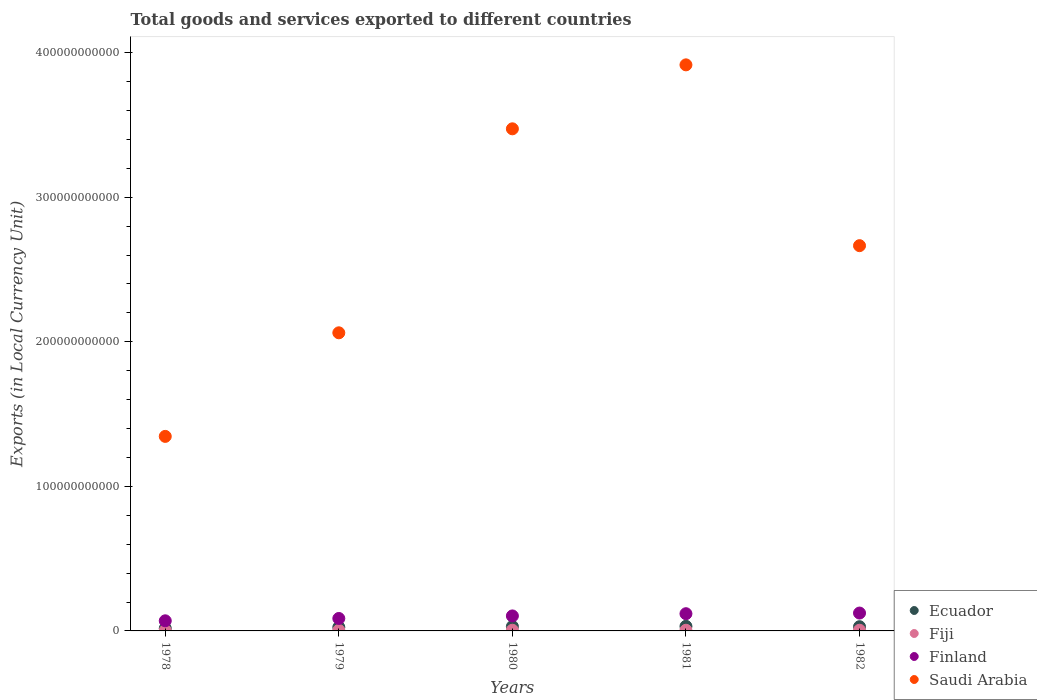What is the Amount of goods and services exports in Saudi Arabia in 1980?
Your response must be concise. 3.47e+11. Across all years, what is the maximum Amount of goods and services exports in Ecuador?
Keep it short and to the point. 3.19e+09. Across all years, what is the minimum Amount of goods and services exports in Ecuador?
Offer a very short reply. 1.76e+09. In which year was the Amount of goods and services exports in Saudi Arabia minimum?
Keep it short and to the point. 1978. What is the total Amount of goods and services exports in Finland in the graph?
Offer a very short reply. 5.03e+1. What is the difference between the Amount of goods and services exports in Ecuador in 1980 and that in 1982?
Your answer should be very brief. 1.45e+08. What is the difference between the Amount of goods and services exports in Finland in 1979 and the Amount of goods and services exports in Fiji in 1982?
Your answer should be very brief. 8.13e+09. What is the average Amount of goods and services exports in Fiji per year?
Provide a short and direct response. 4.18e+08. In the year 1982, what is the difference between the Amount of goods and services exports in Finland and Amount of goods and services exports in Ecuador?
Offer a terse response. 9.44e+09. What is the ratio of the Amount of goods and services exports in Ecuador in 1981 to that in 1982?
Your answer should be compact. 1.09. What is the difference between the highest and the second highest Amount of goods and services exports in Saudi Arabia?
Give a very brief answer. 4.42e+1. What is the difference between the highest and the lowest Amount of goods and services exports in Ecuador?
Keep it short and to the point. 1.43e+09. Is the sum of the Amount of goods and services exports in Ecuador in 1978 and 1982 greater than the maximum Amount of goods and services exports in Saudi Arabia across all years?
Give a very brief answer. No. Is it the case that in every year, the sum of the Amount of goods and services exports in Fiji and Amount of goods and services exports in Saudi Arabia  is greater than the sum of Amount of goods and services exports in Finland and Amount of goods and services exports in Ecuador?
Make the answer very short. Yes. Is it the case that in every year, the sum of the Amount of goods and services exports in Finland and Amount of goods and services exports in Ecuador  is greater than the Amount of goods and services exports in Fiji?
Ensure brevity in your answer.  Yes. Does the Amount of goods and services exports in Ecuador monotonically increase over the years?
Your answer should be compact. No. Is the Amount of goods and services exports in Ecuador strictly less than the Amount of goods and services exports in Saudi Arabia over the years?
Your response must be concise. Yes. How many years are there in the graph?
Your response must be concise. 5. What is the difference between two consecutive major ticks on the Y-axis?
Provide a succinct answer. 1.00e+11. Are the values on the major ticks of Y-axis written in scientific E-notation?
Give a very brief answer. No. Where does the legend appear in the graph?
Ensure brevity in your answer.  Bottom right. How many legend labels are there?
Give a very brief answer. 4. How are the legend labels stacked?
Your response must be concise. Vertical. What is the title of the graph?
Provide a succinct answer. Total goods and services exported to different countries. What is the label or title of the Y-axis?
Give a very brief answer. Exports (in Local Currency Unit). What is the Exports (in Local Currency Unit) of Ecuador in 1978?
Offer a very short reply. 1.76e+09. What is the Exports (in Local Currency Unit) of Fiji in 1978?
Ensure brevity in your answer.  3.00e+08. What is the Exports (in Local Currency Unit) in Finland in 1978?
Make the answer very short. 7.00e+09. What is the Exports (in Local Currency Unit) of Saudi Arabia in 1978?
Your answer should be compact. 1.35e+11. What is the Exports (in Local Currency Unit) in Ecuador in 1979?
Provide a succinct answer. 2.54e+09. What is the Exports (in Local Currency Unit) in Fiji in 1979?
Your answer should be compact. 3.86e+08. What is the Exports (in Local Currency Unit) in Finland in 1979?
Your answer should be very brief. 8.62e+09. What is the Exports (in Local Currency Unit) in Saudi Arabia in 1979?
Your answer should be very brief. 2.06e+11. What is the Exports (in Local Currency Unit) of Ecuador in 1980?
Your response must be concise. 3.06e+09. What is the Exports (in Local Currency Unit) of Fiji in 1980?
Your answer should be very brief. 4.70e+08. What is the Exports (in Local Currency Unit) in Finland in 1980?
Offer a very short reply. 1.04e+1. What is the Exports (in Local Currency Unit) in Saudi Arabia in 1980?
Your response must be concise. 3.47e+11. What is the Exports (in Local Currency Unit) of Ecuador in 1981?
Ensure brevity in your answer.  3.19e+09. What is the Exports (in Local Currency Unit) in Fiji in 1981?
Your answer should be very brief. 4.54e+08. What is the Exports (in Local Currency Unit) of Finland in 1981?
Offer a terse response. 1.19e+1. What is the Exports (in Local Currency Unit) of Saudi Arabia in 1981?
Your answer should be compact. 3.92e+11. What is the Exports (in Local Currency Unit) in Ecuador in 1982?
Provide a succinct answer. 2.92e+09. What is the Exports (in Local Currency Unit) in Fiji in 1982?
Ensure brevity in your answer.  4.81e+08. What is the Exports (in Local Currency Unit) of Finland in 1982?
Offer a terse response. 1.24e+1. What is the Exports (in Local Currency Unit) of Saudi Arabia in 1982?
Your answer should be very brief. 2.67e+11. Across all years, what is the maximum Exports (in Local Currency Unit) in Ecuador?
Give a very brief answer. 3.19e+09. Across all years, what is the maximum Exports (in Local Currency Unit) in Fiji?
Provide a short and direct response. 4.81e+08. Across all years, what is the maximum Exports (in Local Currency Unit) of Finland?
Give a very brief answer. 1.24e+1. Across all years, what is the maximum Exports (in Local Currency Unit) of Saudi Arabia?
Offer a very short reply. 3.92e+11. Across all years, what is the minimum Exports (in Local Currency Unit) in Ecuador?
Make the answer very short. 1.76e+09. Across all years, what is the minimum Exports (in Local Currency Unit) in Fiji?
Your response must be concise. 3.00e+08. Across all years, what is the minimum Exports (in Local Currency Unit) of Finland?
Give a very brief answer. 7.00e+09. Across all years, what is the minimum Exports (in Local Currency Unit) of Saudi Arabia?
Your answer should be compact. 1.35e+11. What is the total Exports (in Local Currency Unit) in Ecuador in the graph?
Your response must be concise. 1.35e+1. What is the total Exports (in Local Currency Unit) of Fiji in the graph?
Keep it short and to the point. 2.09e+09. What is the total Exports (in Local Currency Unit) in Finland in the graph?
Offer a very short reply. 5.03e+1. What is the total Exports (in Local Currency Unit) of Saudi Arabia in the graph?
Your response must be concise. 1.35e+12. What is the difference between the Exports (in Local Currency Unit) of Ecuador in 1978 and that in 1979?
Provide a succinct answer. -7.82e+08. What is the difference between the Exports (in Local Currency Unit) of Fiji in 1978 and that in 1979?
Offer a terse response. -8.63e+07. What is the difference between the Exports (in Local Currency Unit) of Finland in 1978 and that in 1979?
Give a very brief answer. -1.62e+09. What is the difference between the Exports (in Local Currency Unit) of Saudi Arabia in 1978 and that in 1979?
Give a very brief answer. -7.17e+1. What is the difference between the Exports (in Local Currency Unit) in Ecuador in 1978 and that in 1980?
Provide a succinct answer. -1.31e+09. What is the difference between the Exports (in Local Currency Unit) in Fiji in 1978 and that in 1980?
Your answer should be very brief. -1.71e+08. What is the difference between the Exports (in Local Currency Unit) in Finland in 1978 and that in 1980?
Ensure brevity in your answer.  -3.38e+09. What is the difference between the Exports (in Local Currency Unit) in Saudi Arabia in 1978 and that in 1980?
Give a very brief answer. -2.13e+11. What is the difference between the Exports (in Local Currency Unit) of Ecuador in 1978 and that in 1981?
Keep it short and to the point. -1.43e+09. What is the difference between the Exports (in Local Currency Unit) of Fiji in 1978 and that in 1981?
Ensure brevity in your answer.  -1.55e+08. What is the difference between the Exports (in Local Currency Unit) of Finland in 1978 and that in 1981?
Keep it short and to the point. -4.92e+09. What is the difference between the Exports (in Local Currency Unit) in Saudi Arabia in 1978 and that in 1981?
Your response must be concise. -2.57e+11. What is the difference between the Exports (in Local Currency Unit) of Ecuador in 1978 and that in 1982?
Your response must be concise. -1.16e+09. What is the difference between the Exports (in Local Currency Unit) in Fiji in 1978 and that in 1982?
Keep it short and to the point. -1.82e+08. What is the difference between the Exports (in Local Currency Unit) in Finland in 1978 and that in 1982?
Make the answer very short. -5.36e+09. What is the difference between the Exports (in Local Currency Unit) of Saudi Arabia in 1978 and that in 1982?
Provide a succinct answer. -1.32e+11. What is the difference between the Exports (in Local Currency Unit) in Ecuador in 1979 and that in 1980?
Provide a succinct answer. -5.28e+08. What is the difference between the Exports (in Local Currency Unit) of Fiji in 1979 and that in 1980?
Your response must be concise. -8.42e+07. What is the difference between the Exports (in Local Currency Unit) of Finland in 1979 and that in 1980?
Offer a terse response. -1.76e+09. What is the difference between the Exports (in Local Currency Unit) in Saudi Arabia in 1979 and that in 1980?
Offer a terse response. -1.41e+11. What is the difference between the Exports (in Local Currency Unit) in Ecuador in 1979 and that in 1981?
Your answer should be compact. -6.49e+08. What is the difference between the Exports (in Local Currency Unit) of Fiji in 1979 and that in 1981?
Provide a short and direct response. -6.86e+07. What is the difference between the Exports (in Local Currency Unit) in Finland in 1979 and that in 1981?
Your response must be concise. -3.29e+09. What is the difference between the Exports (in Local Currency Unit) of Saudi Arabia in 1979 and that in 1981?
Provide a succinct answer. -1.85e+11. What is the difference between the Exports (in Local Currency Unit) in Ecuador in 1979 and that in 1982?
Keep it short and to the point. -3.82e+08. What is the difference between the Exports (in Local Currency Unit) in Fiji in 1979 and that in 1982?
Provide a succinct answer. -9.55e+07. What is the difference between the Exports (in Local Currency Unit) in Finland in 1979 and that in 1982?
Provide a short and direct response. -3.74e+09. What is the difference between the Exports (in Local Currency Unit) of Saudi Arabia in 1979 and that in 1982?
Offer a terse response. -6.03e+1. What is the difference between the Exports (in Local Currency Unit) in Ecuador in 1980 and that in 1981?
Ensure brevity in your answer.  -1.22e+08. What is the difference between the Exports (in Local Currency Unit) of Fiji in 1980 and that in 1981?
Your response must be concise. 1.56e+07. What is the difference between the Exports (in Local Currency Unit) of Finland in 1980 and that in 1981?
Your answer should be compact. -1.54e+09. What is the difference between the Exports (in Local Currency Unit) in Saudi Arabia in 1980 and that in 1981?
Provide a short and direct response. -4.42e+1. What is the difference between the Exports (in Local Currency Unit) in Ecuador in 1980 and that in 1982?
Keep it short and to the point. 1.45e+08. What is the difference between the Exports (in Local Currency Unit) of Fiji in 1980 and that in 1982?
Your answer should be compact. -1.13e+07. What is the difference between the Exports (in Local Currency Unit) of Finland in 1980 and that in 1982?
Your answer should be compact. -1.98e+09. What is the difference between the Exports (in Local Currency Unit) of Saudi Arabia in 1980 and that in 1982?
Your answer should be very brief. 8.08e+1. What is the difference between the Exports (in Local Currency Unit) of Ecuador in 1981 and that in 1982?
Keep it short and to the point. 2.67e+08. What is the difference between the Exports (in Local Currency Unit) in Fiji in 1981 and that in 1982?
Ensure brevity in your answer.  -2.69e+07. What is the difference between the Exports (in Local Currency Unit) in Finland in 1981 and that in 1982?
Keep it short and to the point. -4.49e+08. What is the difference between the Exports (in Local Currency Unit) in Saudi Arabia in 1981 and that in 1982?
Offer a very short reply. 1.25e+11. What is the difference between the Exports (in Local Currency Unit) of Ecuador in 1978 and the Exports (in Local Currency Unit) of Fiji in 1979?
Your answer should be very brief. 1.37e+09. What is the difference between the Exports (in Local Currency Unit) of Ecuador in 1978 and the Exports (in Local Currency Unit) of Finland in 1979?
Your answer should be very brief. -6.86e+09. What is the difference between the Exports (in Local Currency Unit) in Ecuador in 1978 and the Exports (in Local Currency Unit) in Saudi Arabia in 1979?
Ensure brevity in your answer.  -2.04e+11. What is the difference between the Exports (in Local Currency Unit) in Fiji in 1978 and the Exports (in Local Currency Unit) in Finland in 1979?
Keep it short and to the point. -8.32e+09. What is the difference between the Exports (in Local Currency Unit) in Fiji in 1978 and the Exports (in Local Currency Unit) in Saudi Arabia in 1979?
Provide a short and direct response. -2.06e+11. What is the difference between the Exports (in Local Currency Unit) in Finland in 1978 and the Exports (in Local Currency Unit) in Saudi Arabia in 1979?
Provide a short and direct response. -1.99e+11. What is the difference between the Exports (in Local Currency Unit) of Ecuador in 1978 and the Exports (in Local Currency Unit) of Fiji in 1980?
Your answer should be compact. 1.29e+09. What is the difference between the Exports (in Local Currency Unit) in Ecuador in 1978 and the Exports (in Local Currency Unit) in Finland in 1980?
Offer a very short reply. -8.62e+09. What is the difference between the Exports (in Local Currency Unit) in Ecuador in 1978 and the Exports (in Local Currency Unit) in Saudi Arabia in 1980?
Your response must be concise. -3.46e+11. What is the difference between the Exports (in Local Currency Unit) in Fiji in 1978 and the Exports (in Local Currency Unit) in Finland in 1980?
Your answer should be very brief. -1.01e+1. What is the difference between the Exports (in Local Currency Unit) in Fiji in 1978 and the Exports (in Local Currency Unit) in Saudi Arabia in 1980?
Provide a short and direct response. -3.47e+11. What is the difference between the Exports (in Local Currency Unit) of Finland in 1978 and the Exports (in Local Currency Unit) of Saudi Arabia in 1980?
Your answer should be very brief. -3.40e+11. What is the difference between the Exports (in Local Currency Unit) of Ecuador in 1978 and the Exports (in Local Currency Unit) of Fiji in 1981?
Offer a terse response. 1.30e+09. What is the difference between the Exports (in Local Currency Unit) in Ecuador in 1978 and the Exports (in Local Currency Unit) in Finland in 1981?
Keep it short and to the point. -1.02e+1. What is the difference between the Exports (in Local Currency Unit) in Ecuador in 1978 and the Exports (in Local Currency Unit) in Saudi Arabia in 1981?
Give a very brief answer. -3.90e+11. What is the difference between the Exports (in Local Currency Unit) of Fiji in 1978 and the Exports (in Local Currency Unit) of Finland in 1981?
Keep it short and to the point. -1.16e+1. What is the difference between the Exports (in Local Currency Unit) of Fiji in 1978 and the Exports (in Local Currency Unit) of Saudi Arabia in 1981?
Ensure brevity in your answer.  -3.91e+11. What is the difference between the Exports (in Local Currency Unit) of Finland in 1978 and the Exports (in Local Currency Unit) of Saudi Arabia in 1981?
Give a very brief answer. -3.85e+11. What is the difference between the Exports (in Local Currency Unit) in Ecuador in 1978 and the Exports (in Local Currency Unit) in Fiji in 1982?
Make the answer very short. 1.27e+09. What is the difference between the Exports (in Local Currency Unit) in Ecuador in 1978 and the Exports (in Local Currency Unit) in Finland in 1982?
Offer a very short reply. -1.06e+1. What is the difference between the Exports (in Local Currency Unit) of Ecuador in 1978 and the Exports (in Local Currency Unit) of Saudi Arabia in 1982?
Provide a short and direct response. -2.65e+11. What is the difference between the Exports (in Local Currency Unit) in Fiji in 1978 and the Exports (in Local Currency Unit) in Finland in 1982?
Your answer should be compact. -1.21e+1. What is the difference between the Exports (in Local Currency Unit) of Fiji in 1978 and the Exports (in Local Currency Unit) of Saudi Arabia in 1982?
Offer a terse response. -2.66e+11. What is the difference between the Exports (in Local Currency Unit) in Finland in 1978 and the Exports (in Local Currency Unit) in Saudi Arabia in 1982?
Offer a very short reply. -2.60e+11. What is the difference between the Exports (in Local Currency Unit) of Ecuador in 1979 and the Exports (in Local Currency Unit) of Fiji in 1980?
Your response must be concise. 2.07e+09. What is the difference between the Exports (in Local Currency Unit) of Ecuador in 1979 and the Exports (in Local Currency Unit) of Finland in 1980?
Your response must be concise. -7.84e+09. What is the difference between the Exports (in Local Currency Unit) of Ecuador in 1979 and the Exports (in Local Currency Unit) of Saudi Arabia in 1980?
Make the answer very short. -3.45e+11. What is the difference between the Exports (in Local Currency Unit) in Fiji in 1979 and the Exports (in Local Currency Unit) in Finland in 1980?
Your answer should be very brief. -9.99e+09. What is the difference between the Exports (in Local Currency Unit) in Fiji in 1979 and the Exports (in Local Currency Unit) in Saudi Arabia in 1980?
Offer a terse response. -3.47e+11. What is the difference between the Exports (in Local Currency Unit) in Finland in 1979 and the Exports (in Local Currency Unit) in Saudi Arabia in 1980?
Provide a succinct answer. -3.39e+11. What is the difference between the Exports (in Local Currency Unit) in Ecuador in 1979 and the Exports (in Local Currency Unit) in Fiji in 1981?
Offer a very short reply. 2.08e+09. What is the difference between the Exports (in Local Currency Unit) of Ecuador in 1979 and the Exports (in Local Currency Unit) of Finland in 1981?
Provide a short and direct response. -9.37e+09. What is the difference between the Exports (in Local Currency Unit) in Ecuador in 1979 and the Exports (in Local Currency Unit) in Saudi Arabia in 1981?
Give a very brief answer. -3.89e+11. What is the difference between the Exports (in Local Currency Unit) of Fiji in 1979 and the Exports (in Local Currency Unit) of Finland in 1981?
Your answer should be very brief. -1.15e+1. What is the difference between the Exports (in Local Currency Unit) in Fiji in 1979 and the Exports (in Local Currency Unit) in Saudi Arabia in 1981?
Ensure brevity in your answer.  -3.91e+11. What is the difference between the Exports (in Local Currency Unit) of Finland in 1979 and the Exports (in Local Currency Unit) of Saudi Arabia in 1981?
Your answer should be very brief. -3.83e+11. What is the difference between the Exports (in Local Currency Unit) in Ecuador in 1979 and the Exports (in Local Currency Unit) in Fiji in 1982?
Give a very brief answer. 2.06e+09. What is the difference between the Exports (in Local Currency Unit) in Ecuador in 1979 and the Exports (in Local Currency Unit) in Finland in 1982?
Provide a short and direct response. -9.82e+09. What is the difference between the Exports (in Local Currency Unit) of Ecuador in 1979 and the Exports (in Local Currency Unit) of Saudi Arabia in 1982?
Ensure brevity in your answer.  -2.64e+11. What is the difference between the Exports (in Local Currency Unit) in Fiji in 1979 and the Exports (in Local Currency Unit) in Finland in 1982?
Provide a short and direct response. -1.20e+1. What is the difference between the Exports (in Local Currency Unit) in Fiji in 1979 and the Exports (in Local Currency Unit) in Saudi Arabia in 1982?
Your answer should be very brief. -2.66e+11. What is the difference between the Exports (in Local Currency Unit) of Finland in 1979 and the Exports (in Local Currency Unit) of Saudi Arabia in 1982?
Give a very brief answer. -2.58e+11. What is the difference between the Exports (in Local Currency Unit) in Ecuador in 1980 and the Exports (in Local Currency Unit) in Fiji in 1981?
Your answer should be compact. 2.61e+09. What is the difference between the Exports (in Local Currency Unit) of Ecuador in 1980 and the Exports (in Local Currency Unit) of Finland in 1981?
Ensure brevity in your answer.  -8.85e+09. What is the difference between the Exports (in Local Currency Unit) in Ecuador in 1980 and the Exports (in Local Currency Unit) in Saudi Arabia in 1981?
Your response must be concise. -3.89e+11. What is the difference between the Exports (in Local Currency Unit) of Fiji in 1980 and the Exports (in Local Currency Unit) of Finland in 1981?
Provide a succinct answer. -1.14e+1. What is the difference between the Exports (in Local Currency Unit) of Fiji in 1980 and the Exports (in Local Currency Unit) of Saudi Arabia in 1981?
Ensure brevity in your answer.  -3.91e+11. What is the difference between the Exports (in Local Currency Unit) of Finland in 1980 and the Exports (in Local Currency Unit) of Saudi Arabia in 1981?
Your response must be concise. -3.81e+11. What is the difference between the Exports (in Local Currency Unit) of Ecuador in 1980 and the Exports (in Local Currency Unit) of Fiji in 1982?
Give a very brief answer. 2.58e+09. What is the difference between the Exports (in Local Currency Unit) in Ecuador in 1980 and the Exports (in Local Currency Unit) in Finland in 1982?
Your response must be concise. -9.29e+09. What is the difference between the Exports (in Local Currency Unit) in Ecuador in 1980 and the Exports (in Local Currency Unit) in Saudi Arabia in 1982?
Your answer should be very brief. -2.63e+11. What is the difference between the Exports (in Local Currency Unit) of Fiji in 1980 and the Exports (in Local Currency Unit) of Finland in 1982?
Your response must be concise. -1.19e+1. What is the difference between the Exports (in Local Currency Unit) in Fiji in 1980 and the Exports (in Local Currency Unit) in Saudi Arabia in 1982?
Ensure brevity in your answer.  -2.66e+11. What is the difference between the Exports (in Local Currency Unit) of Finland in 1980 and the Exports (in Local Currency Unit) of Saudi Arabia in 1982?
Your response must be concise. -2.56e+11. What is the difference between the Exports (in Local Currency Unit) in Ecuador in 1981 and the Exports (in Local Currency Unit) in Fiji in 1982?
Keep it short and to the point. 2.71e+09. What is the difference between the Exports (in Local Currency Unit) in Ecuador in 1981 and the Exports (in Local Currency Unit) in Finland in 1982?
Make the answer very short. -9.17e+09. What is the difference between the Exports (in Local Currency Unit) in Ecuador in 1981 and the Exports (in Local Currency Unit) in Saudi Arabia in 1982?
Your answer should be compact. -2.63e+11. What is the difference between the Exports (in Local Currency Unit) of Fiji in 1981 and the Exports (in Local Currency Unit) of Finland in 1982?
Your answer should be very brief. -1.19e+1. What is the difference between the Exports (in Local Currency Unit) of Fiji in 1981 and the Exports (in Local Currency Unit) of Saudi Arabia in 1982?
Your answer should be compact. -2.66e+11. What is the difference between the Exports (in Local Currency Unit) of Finland in 1981 and the Exports (in Local Currency Unit) of Saudi Arabia in 1982?
Provide a succinct answer. -2.55e+11. What is the average Exports (in Local Currency Unit) in Ecuador per year?
Your response must be concise. 2.69e+09. What is the average Exports (in Local Currency Unit) in Fiji per year?
Keep it short and to the point. 4.18e+08. What is the average Exports (in Local Currency Unit) in Finland per year?
Your response must be concise. 1.01e+1. What is the average Exports (in Local Currency Unit) in Saudi Arabia per year?
Give a very brief answer. 2.69e+11. In the year 1978, what is the difference between the Exports (in Local Currency Unit) of Ecuador and Exports (in Local Currency Unit) of Fiji?
Ensure brevity in your answer.  1.46e+09. In the year 1978, what is the difference between the Exports (in Local Currency Unit) of Ecuador and Exports (in Local Currency Unit) of Finland?
Your answer should be compact. -5.24e+09. In the year 1978, what is the difference between the Exports (in Local Currency Unit) of Ecuador and Exports (in Local Currency Unit) of Saudi Arabia?
Offer a very short reply. -1.33e+11. In the year 1978, what is the difference between the Exports (in Local Currency Unit) of Fiji and Exports (in Local Currency Unit) of Finland?
Give a very brief answer. -6.70e+09. In the year 1978, what is the difference between the Exports (in Local Currency Unit) in Fiji and Exports (in Local Currency Unit) in Saudi Arabia?
Your response must be concise. -1.34e+11. In the year 1978, what is the difference between the Exports (in Local Currency Unit) in Finland and Exports (in Local Currency Unit) in Saudi Arabia?
Provide a succinct answer. -1.28e+11. In the year 1979, what is the difference between the Exports (in Local Currency Unit) of Ecuador and Exports (in Local Currency Unit) of Fiji?
Your answer should be very brief. 2.15e+09. In the year 1979, what is the difference between the Exports (in Local Currency Unit) in Ecuador and Exports (in Local Currency Unit) in Finland?
Keep it short and to the point. -6.08e+09. In the year 1979, what is the difference between the Exports (in Local Currency Unit) in Ecuador and Exports (in Local Currency Unit) in Saudi Arabia?
Make the answer very short. -2.04e+11. In the year 1979, what is the difference between the Exports (in Local Currency Unit) of Fiji and Exports (in Local Currency Unit) of Finland?
Provide a succinct answer. -8.23e+09. In the year 1979, what is the difference between the Exports (in Local Currency Unit) in Fiji and Exports (in Local Currency Unit) in Saudi Arabia?
Make the answer very short. -2.06e+11. In the year 1979, what is the difference between the Exports (in Local Currency Unit) of Finland and Exports (in Local Currency Unit) of Saudi Arabia?
Keep it short and to the point. -1.98e+11. In the year 1980, what is the difference between the Exports (in Local Currency Unit) in Ecuador and Exports (in Local Currency Unit) in Fiji?
Give a very brief answer. 2.59e+09. In the year 1980, what is the difference between the Exports (in Local Currency Unit) in Ecuador and Exports (in Local Currency Unit) in Finland?
Make the answer very short. -7.31e+09. In the year 1980, what is the difference between the Exports (in Local Currency Unit) of Ecuador and Exports (in Local Currency Unit) of Saudi Arabia?
Keep it short and to the point. -3.44e+11. In the year 1980, what is the difference between the Exports (in Local Currency Unit) in Fiji and Exports (in Local Currency Unit) in Finland?
Your answer should be very brief. -9.90e+09. In the year 1980, what is the difference between the Exports (in Local Currency Unit) in Fiji and Exports (in Local Currency Unit) in Saudi Arabia?
Make the answer very short. -3.47e+11. In the year 1980, what is the difference between the Exports (in Local Currency Unit) of Finland and Exports (in Local Currency Unit) of Saudi Arabia?
Your answer should be compact. -3.37e+11. In the year 1981, what is the difference between the Exports (in Local Currency Unit) of Ecuador and Exports (in Local Currency Unit) of Fiji?
Your answer should be very brief. 2.73e+09. In the year 1981, what is the difference between the Exports (in Local Currency Unit) in Ecuador and Exports (in Local Currency Unit) in Finland?
Provide a succinct answer. -8.72e+09. In the year 1981, what is the difference between the Exports (in Local Currency Unit) in Ecuador and Exports (in Local Currency Unit) in Saudi Arabia?
Your answer should be very brief. -3.88e+11. In the year 1981, what is the difference between the Exports (in Local Currency Unit) of Fiji and Exports (in Local Currency Unit) of Finland?
Make the answer very short. -1.15e+1. In the year 1981, what is the difference between the Exports (in Local Currency Unit) in Fiji and Exports (in Local Currency Unit) in Saudi Arabia?
Ensure brevity in your answer.  -3.91e+11. In the year 1981, what is the difference between the Exports (in Local Currency Unit) in Finland and Exports (in Local Currency Unit) in Saudi Arabia?
Make the answer very short. -3.80e+11. In the year 1982, what is the difference between the Exports (in Local Currency Unit) in Ecuador and Exports (in Local Currency Unit) in Fiji?
Your answer should be compact. 2.44e+09. In the year 1982, what is the difference between the Exports (in Local Currency Unit) of Ecuador and Exports (in Local Currency Unit) of Finland?
Make the answer very short. -9.44e+09. In the year 1982, what is the difference between the Exports (in Local Currency Unit) in Ecuador and Exports (in Local Currency Unit) in Saudi Arabia?
Make the answer very short. -2.64e+11. In the year 1982, what is the difference between the Exports (in Local Currency Unit) in Fiji and Exports (in Local Currency Unit) in Finland?
Ensure brevity in your answer.  -1.19e+1. In the year 1982, what is the difference between the Exports (in Local Currency Unit) of Fiji and Exports (in Local Currency Unit) of Saudi Arabia?
Make the answer very short. -2.66e+11. In the year 1982, what is the difference between the Exports (in Local Currency Unit) of Finland and Exports (in Local Currency Unit) of Saudi Arabia?
Ensure brevity in your answer.  -2.54e+11. What is the ratio of the Exports (in Local Currency Unit) in Ecuador in 1978 to that in 1979?
Your response must be concise. 0.69. What is the ratio of the Exports (in Local Currency Unit) of Fiji in 1978 to that in 1979?
Offer a very short reply. 0.78. What is the ratio of the Exports (in Local Currency Unit) of Finland in 1978 to that in 1979?
Your answer should be compact. 0.81. What is the ratio of the Exports (in Local Currency Unit) of Saudi Arabia in 1978 to that in 1979?
Make the answer very short. 0.65. What is the ratio of the Exports (in Local Currency Unit) in Ecuador in 1978 to that in 1980?
Provide a succinct answer. 0.57. What is the ratio of the Exports (in Local Currency Unit) of Fiji in 1978 to that in 1980?
Make the answer very short. 0.64. What is the ratio of the Exports (in Local Currency Unit) of Finland in 1978 to that in 1980?
Provide a short and direct response. 0.67. What is the ratio of the Exports (in Local Currency Unit) of Saudi Arabia in 1978 to that in 1980?
Provide a short and direct response. 0.39. What is the ratio of the Exports (in Local Currency Unit) in Ecuador in 1978 to that in 1981?
Give a very brief answer. 0.55. What is the ratio of the Exports (in Local Currency Unit) in Fiji in 1978 to that in 1981?
Keep it short and to the point. 0.66. What is the ratio of the Exports (in Local Currency Unit) in Finland in 1978 to that in 1981?
Provide a succinct answer. 0.59. What is the ratio of the Exports (in Local Currency Unit) of Saudi Arabia in 1978 to that in 1981?
Your answer should be very brief. 0.34. What is the ratio of the Exports (in Local Currency Unit) of Ecuador in 1978 to that in 1982?
Offer a very short reply. 0.6. What is the ratio of the Exports (in Local Currency Unit) of Fiji in 1978 to that in 1982?
Make the answer very short. 0.62. What is the ratio of the Exports (in Local Currency Unit) in Finland in 1978 to that in 1982?
Give a very brief answer. 0.57. What is the ratio of the Exports (in Local Currency Unit) in Saudi Arabia in 1978 to that in 1982?
Provide a short and direct response. 0.5. What is the ratio of the Exports (in Local Currency Unit) of Ecuador in 1979 to that in 1980?
Your response must be concise. 0.83. What is the ratio of the Exports (in Local Currency Unit) in Fiji in 1979 to that in 1980?
Make the answer very short. 0.82. What is the ratio of the Exports (in Local Currency Unit) in Finland in 1979 to that in 1980?
Offer a terse response. 0.83. What is the ratio of the Exports (in Local Currency Unit) in Saudi Arabia in 1979 to that in 1980?
Keep it short and to the point. 0.59. What is the ratio of the Exports (in Local Currency Unit) of Ecuador in 1979 to that in 1981?
Your response must be concise. 0.8. What is the ratio of the Exports (in Local Currency Unit) in Fiji in 1979 to that in 1981?
Your response must be concise. 0.85. What is the ratio of the Exports (in Local Currency Unit) of Finland in 1979 to that in 1981?
Offer a terse response. 0.72. What is the ratio of the Exports (in Local Currency Unit) in Saudi Arabia in 1979 to that in 1981?
Provide a short and direct response. 0.53. What is the ratio of the Exports (in Local Currency Unit) of Ecuador in 1979 to that in 1982?
Ensure brevity in your answer.  0.87. What is the ratio of the Exports (in Local Currency Unit) of Fiji in 1979 to that in 1982?
Provide a succinct answer. 0.8. What is the ratio of the Exports (in Local Currency Unit) of Finland in 1979 to that in 1982?
Give a very brief answer. 0.7. What is the ratio of the Exports (in Local Currency Unit) in Saudi Arabia in 1979 to that in 1982?
Offer a terse response. 0.77. What is the ratio of the Exports (in Local Currency Unit) of Ecuador in 1980 to that in 1981?
Provide a succinct answer. 0.96. What is the ratio of the Exports (in Local Currency Unit) in Fiji in 1980 to that in 1981?
Offer a terse response. 1.03. What is the ratio of the Exports (in Local Currency Unit) of Finland in 1980 to that in 1981?
Your response must be concise. 0.87. What is the ratio of the Exports (in Local Currency Unit) in Saudi Arabia in 1980 to that in 1981?
Offer a very short reply. 0.89. What is the ratio of the Exports (in Local Currency Unit) in Ecuador in 1980 to that in 1982?
Keep it short and to the point. 1.05. What is the ratio of the Exports (in Local Currency Unit) of Fiji in 1980 to that in 1982?
Provide a succinct answer. 0.98. What is the ratio of the Exports (in Local Currency Unit) in Finland in 1980 to that in 1982?
Give a very brief answer. 0.84. What is the ratio of the Exports (in Local Currency Unit) in Saudi Arabia in 1980 to that in 1982?
Your response must be concise. 1.3. What is the ratio of the Exports (in Local Currency Unit) in Ecuador in 1981 to that in 1982?
Offer a very short reply. 1.09. What is the ratio of the Exports (in Local Currency Unit) of Fiji in 1981 to that in 1982?
Make the answer very short. 0.94. What is the ratio of the Exports (in Local Currency Unit) in Finland in 1981 to that in 1982?
Provide a short and direct response. 0.96. What is the ratio of the Exports (in Local Currency Unit) in Saudi Arabia in 1981 to that in 1982?
Your answer should be very brief. 1.47. What is the difference between the highest and the second highest Exports (in Local Currency Unit) in Ecuador?
Ensure brevity in your answer.  1.22e+08. What is the difference between the highest and the second highest Exports (in Local Currency Unit) of Fiji?
Provide a succinct answer. 1.13e+07. What is the difference between the highest and the second highest Exports (in Local Currency Unit) of Finland?
Offer a very short reply. 4.49e+08. What is the difference between the highest and the second highest Exports (in Local Currency Unit) of Saudi Arabia?
Give a very brief answer. 4.42e+1. What is the difference between the highest and the lowest Exports (in Local Currency Unit) in Ecuador?
Make the answer very short. 1.43e+09. What is the difference between the highest and the lowest Exports (in Local Currency Unit) in Fiji?
Your response must be concise. 1.82e+08. What is the difference between the highest and the lowest Exports (in Local Currency Unit) of Finland?
Offer a terse response. 5.36e+09. What is the difference between the highest and the lowest Exports (in Local Currency Unit) in Saudi Arabia?
Offer a terse response. 2.57e+11. 